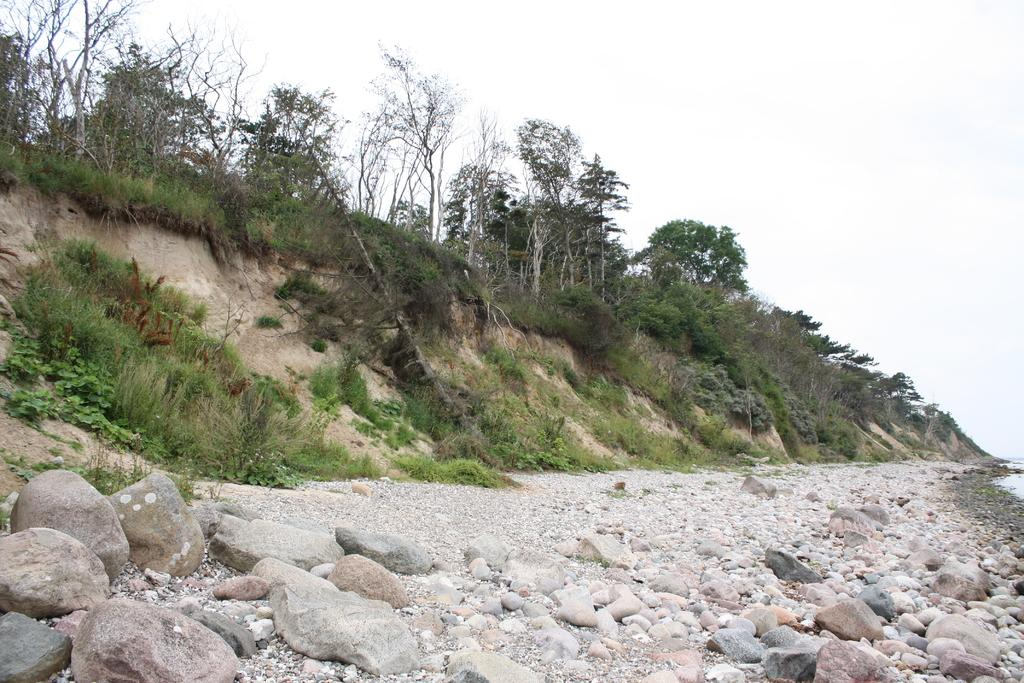What type of objects are located at the bottom of the image? There are stones at the bottom of the image. What can be seen in the middle of the image? There are trees in the middle of the image. What is visible at the top of the image? The sky is visible at the top of the image. Is there any quicksand present in the image? There is no quicksand present in the image. Can you tell me how many porters are visible in the image? There are no porters present in the image. 